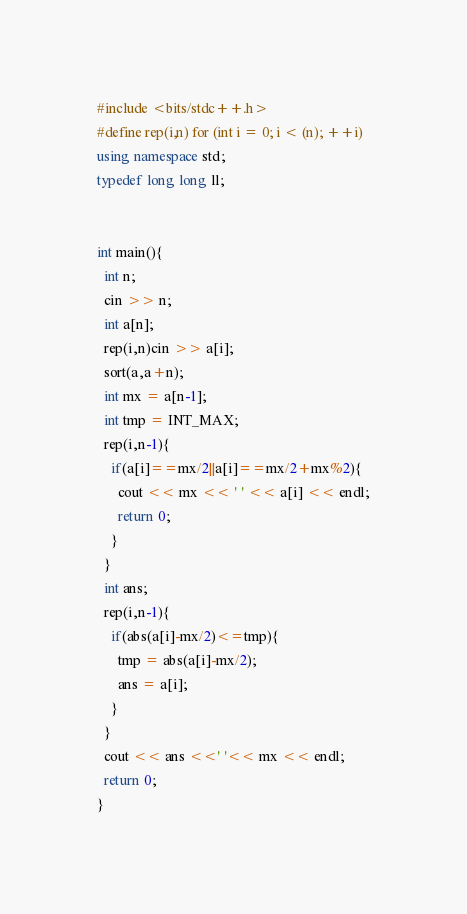Convert code to text. <code><loc_0><loc_0><loc_500><loc_500><_C++_>#include <bits/stdc++.h>
#define rep(i,n) for (int i = 0; i < (n); ++i)
using namespace std;
typedef long long ll;


int main(){
  int n;
  cin >> n;
  int a[n];
  rep(i,n)cin >> a[i];
  sort(a,a+n);
  int mx = a[n-1];
  int tmp = INT_MAX;
  rep(i,n-1){
    if(a[i]==mx/2||a[i]==mx/2+mx%2){
      cout << mx << ' ' << a[i] << endl;
      return 0;
    }
  }
  int ans;
  rep(i,n-1){
    if(abs(a[i]-mx/2)<=tmp){
      tmp = abs(a[i]-mx/2);
      ans = a[i];
    }
  }
  cout << ans <<' '<< mx << endl;
  return 0;
}
</code> 